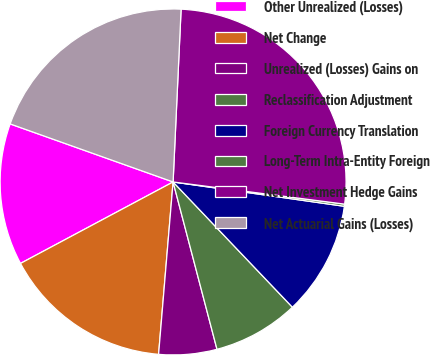<chart> <loc_0><loc_0><loc_500><loc_500><pie_chart><fcel>Other Unrealized (Losses)<fcel>Net Change<fcel>Unrealized (Losses) Gains on<fcel>Reclassification Adjustment<fcel>Foreign Currency Translation<fcel>Long-Term Intra-Entity Foreign<fcel>Net Investment Hedge Gains<fcel>Net Actuarial Gains (Losses)<nl><fcel>13.25%<fcel>15.86%<fcel>5.42%<fcel>8.03%<fcel>10.64%<fcel>0.2%<fcel>26.31%<fcel>20.29%<nl></chart> 